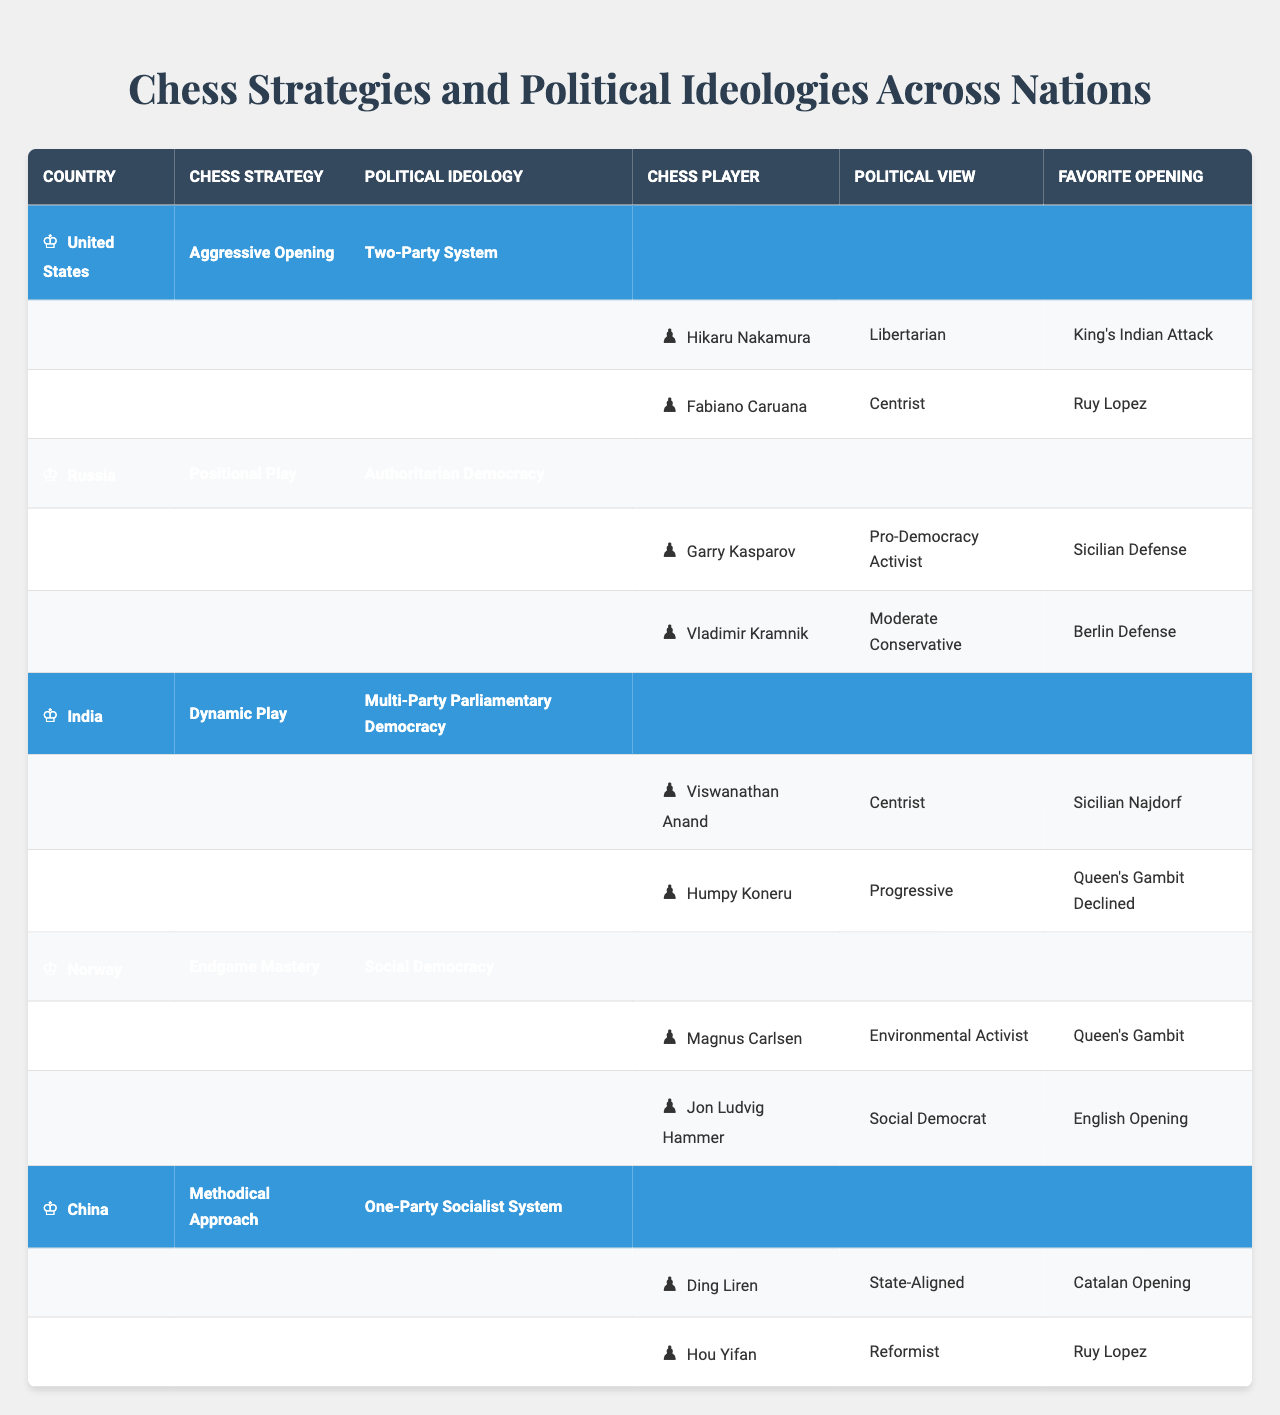What chess strategy is used by India? The table lists the countries along with their chess strategies. Looking at India, the chess strategy mentioned is "Dynamic Play."
Answer: Dynamic Play Which country has a political ideology defined as a "Two-Party System"? By reviewing the political ideologies in the table, the United States is characterized by the "Two-Party System."
Answer: United States Who is the chess player from Russia known as a Pro-Democracy Activist? The table shows that Garry Kasparov from Russia is listed as a Pro-Democracy Activist.
Answer: Garry Kasparov What is the favorite opening of Magnus Carlsen? According to the table, Magnus Carlsen's favorite opening is the "Queen's Gambit."
Answer: Queen's Gambit How many chess players from China are mentioned in the table? The table includes two chess players from China: Ding Liren and Hou Yifan. Therefore, the count is 2.
Answer: 2 Is it true that India's political ideology is a Multi-Party Parliamentary Democracy? The table shows India's political ideology, specifically stating "Multi-Party Parliamentary Democracy," indicating that the statement is indeed true.
Answer: True Which country's chess strategy is described as "Endgame Mastery" and who are its players? Norway employs "Endgame Mastery" as its chess strategy. The players from Norway listed in the table are Magnus Carlsen and Jon Ludvig Hammer.
Answer: Norway; Magnus Carlsen, Jon Ludvig Hammer What are the political views of the chess players from the United States? From the table, Hikaru Nakamura's political view is "Libertarian," and Fabiano Caruana's view is "Centrist."
Answer: Libertarian, Centrist Compare the political ideologies of countries with "Aggressive Opening" and "Positional Play" chess strategies. The United States has a "Two-Party System" (Aggressive Opening), while Russia has an "Authoritarian Democracy" (Positional Play). Thus, these two political systems differ significantly.
Answer: Two-Party System; Authoritarian Democracy Which chess player's favorite opening aligns with the political view of being state-aligned? Ding Liren from China has a political view of "State-Aligned" and his favorite opening is the "Catalan Opening," as listed in the table.
Answer: Catalan Opening 